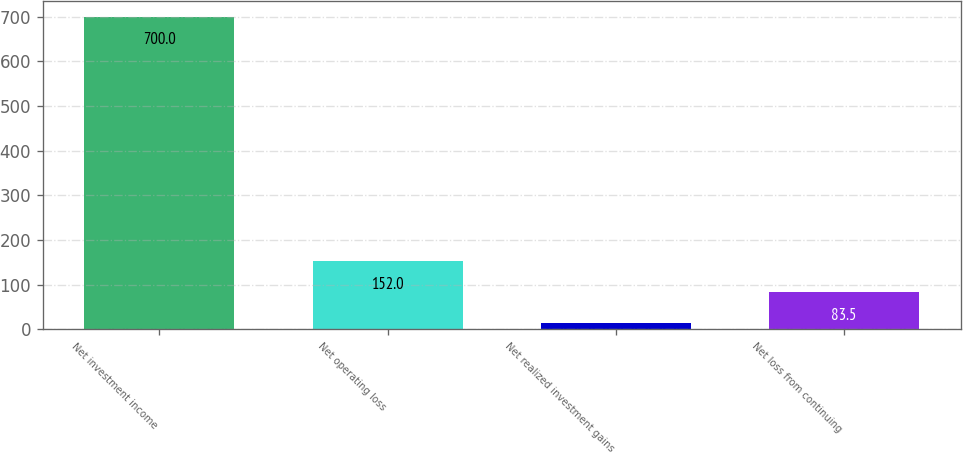<chart> <loc_0><loc_0><loc_500><loc_500><bar_chart><fcel>Net investment income<fcel>Net operating loss<fcel>Net realized investment gains<fcel>Net loss from continuing<nl><fcel>700<fcel>152<fcel>15<fcel>83.5<nl></chart> 